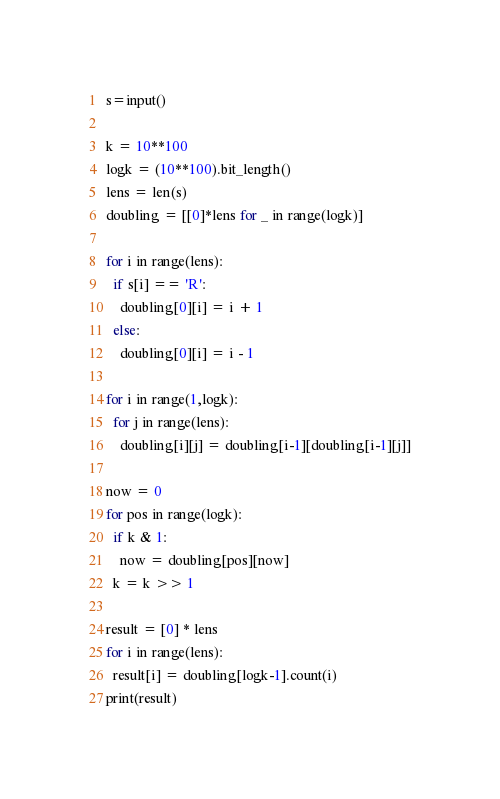Convert code to text. <code><loc_0><loc_0><loc_500><loc_500><_Python_>s=input()

k = 10**100
logk = (10**100).bit_length()
lens = len(s)
doubling = [[0]*lens for _ in range(logk)]

for i in range(lens):
  if s[i] == 'R':
    doubling[0][i] = i + 1
  else:
    doubling[0][i] = i - 1

for i in range(1,logk):
  for j in range(lens):
    doubling[i][j] = doubling[i-1][doubling[i-1][j]]

now = 0
for pos in range(logk):
  if k & 1:
    now = doubling[pos][now]
  k = k >> 1

result = [0] * lens
for i in range(lens):
  result[i] = doubling[logk-1].count(i) 
print(result)</code> 